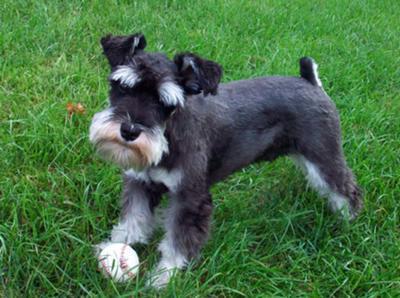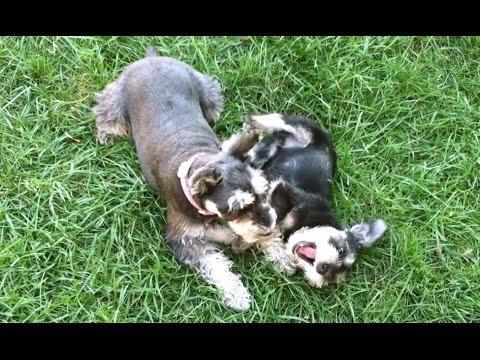The first image is the image on the left, the second image is the image on the right. Assess this claim about the two images: "A ball is in the grass in front of a dog in one image.". Correct or not? Answer yes or no. Yes. 